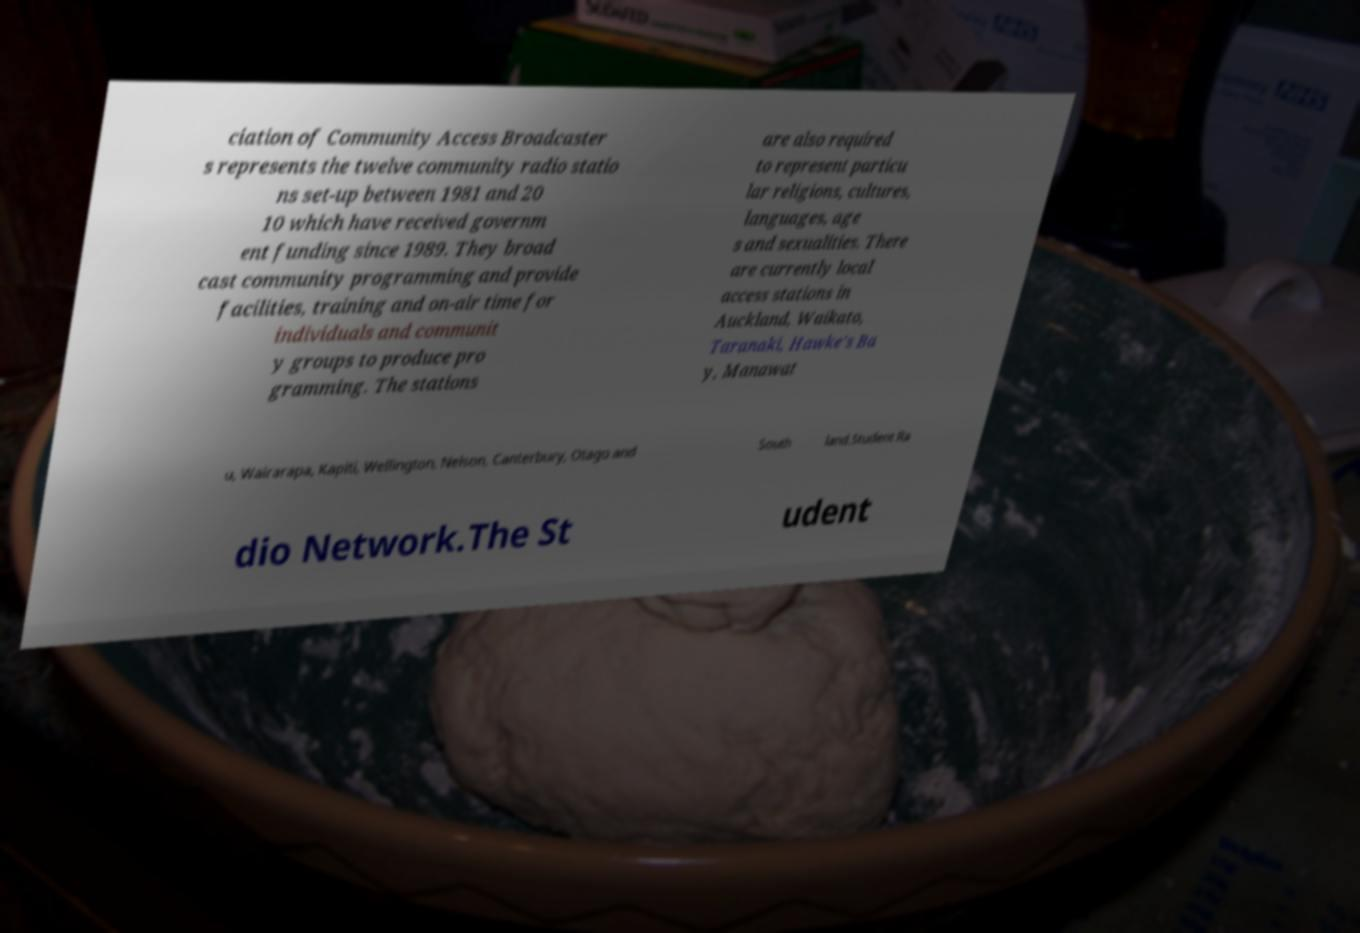What messages or text are displayed in this image? I need them in a readable, typed format. ciation of Community Access Broadcaster s represents the twelve community radio statio ns set-up between 1981 and 20 10 which have received governm ent funding since 1989. They broad cast community programming and provide facilities, training and on-air time for individuals and communit y groups to produce pro gramming. The stations are also required to represent particu lar religions, cultures, languages, age s and sexualities. There are currently local access stations in Auckland, Waikato, Taranaki, Hawke's Ba y, Manawat u, Wairarapa, Kapiti, Wellington, Nelson, Canterbury, Otago and South land.Student Ra dio Network.The St udent 